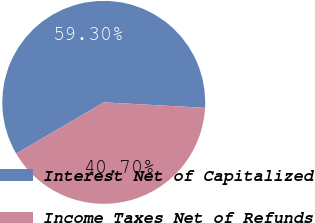Convert chart to OTSL. <chart><loc_0><loc_0><loc_500><loc_500><pie_chart><fcel>Interest Net of Capitalized<fcel>Income Taxes Net of Refunds<nl><fcel>59.3%<fcel>40.7%<nl></chart> 